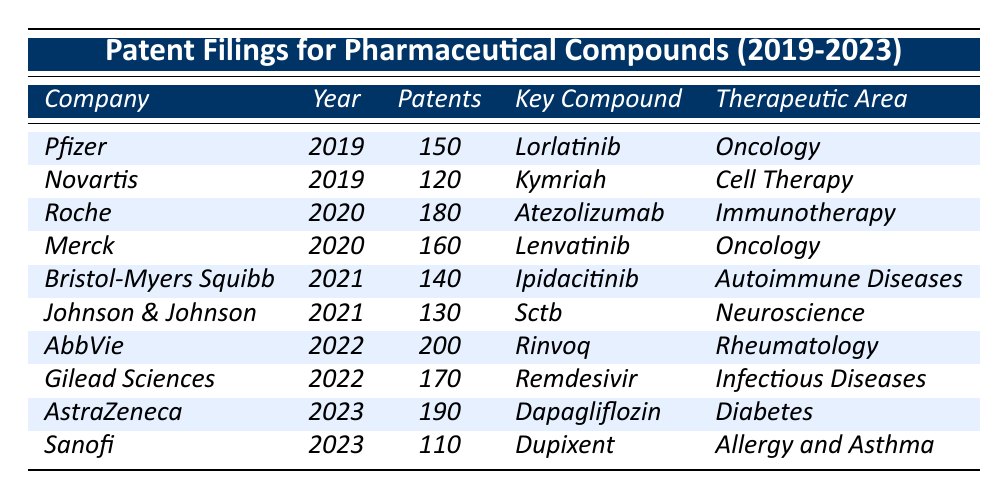What company had the highest number of patent filings in 2022? In 2022, AbbVie had 200 patent filings, which is the highest number compared to Gilead Sciences, which had 170.
Answer: AbbVie How many patents did Pfizer file in 2019? Pfizer filed 150 patents in 2019 as mentioned in the table.
Answer: 150 Did Roche file more patents than Merck in 2020? Roche filed 180 patents while Merck filed 160 patents in 2020, so yes, Roche filed more patents.
Answer: Yes What is the therapeutic area for the key compound Rinvoq? The key compound Rinvoq belongs to the therapeutic area of Rheumatology, as stated in the table.
Answer: Rheumatology What is the total number of patents filed by Johnson & Johnson and Bristol-Myers Squibb in 2021? Johnson & Johnson filed 130 patents and Bristol-Myers Squibb filed 140 patents in 2021. Summing them gives 130 + 140 = 270.
Answer: 270 Which company had the least patent filings in 2023? In 2023, Sanofi had the least patent filings with 110 compared to AstraZeneca's 190.
Answer: Sanofi What was the key compound for Gilead Sciences in 2022? The key compound for Gilead Sciences in 2022 is Remdesivir, as outlined in the table.
Answer: Remdesivir How many patent filings did the top three companies (by patent filings) cumulatively have from 2019 to 2023? The top three companies are AbbVie (200), AstraZeneca (190), and Roche (180). The total is 200 + 190 + 180 = 570 patents.
Answer: 570 Which year had the highest patent filings by any company, and what were the total filings for that year? In 2022, the total number of patents filed by AbbVie (200) and Gilead Sciences (170) reached 370 patents, which is the highest in any single year from 2019 to 2023.
Answer: 370 Is it true that all companies listed filed patents every year from 2019 to 2023? No, some companies do not have filings in certain years; for instance, there are no filings for Pfizer, Novartis, or others beyond their listed years.
Answer: No 